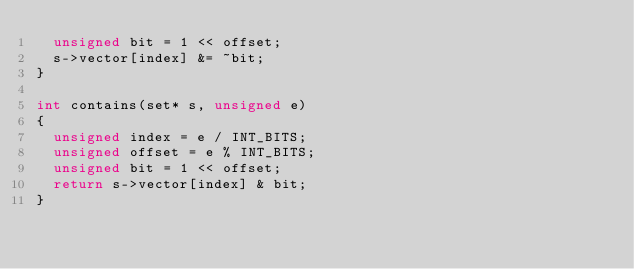<code> <loc_0><loc_0><loc_500><loc_500><_C_>  unsigned bit = 1 << offset;
  s->vector[index] &= ~bit;
}

int contains(set* s, unsigned e)
{
  unsigned index = e / INT_BITS;
  unsigned offset = e % INT_BITS;
  unsigned bit = 1 << offset;
  return s->vector[index] & bit;
}
</code> 